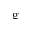Convert formula to latex. <formula><loc_0><loc_0><loc_500><loc_500>g</formula> 